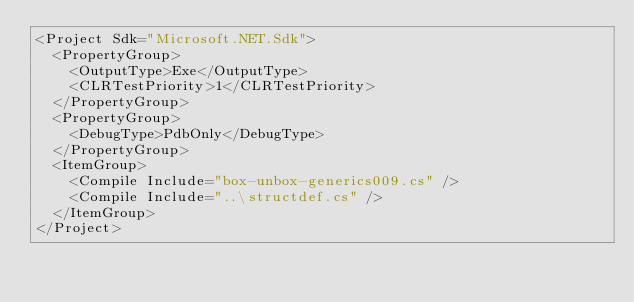Convert code to text. <code><loc_0><loc_0><loc_500><loc_500><_XML_><Project Sdk="Microsoft.NET.Sdk">
  <PropertyGroup>
    <OutputType>Exe</OutputType>
    <CLRTestPriority>1</CLRTestPriority>
  </PropertyGroup>
  <PropertyGroup>
    <DebugType>PdbOnly</DebugType>
  </PropertyGroup>
  <ItemGroup>
    <Compile Include="box-unbox-generics009.cs" />
    <Compile Include="..\structdef.cs" />
  </ItemGroup>
</Project>
</code> 